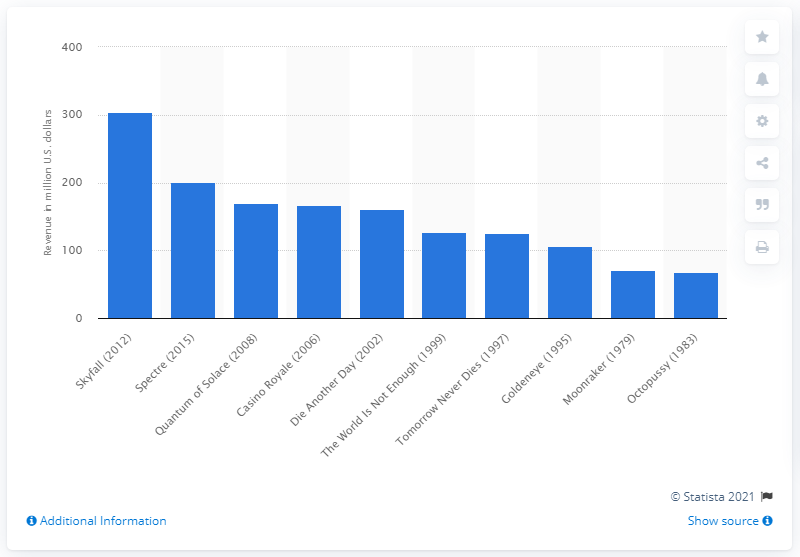List a handful of essential elements in this visual. The total gross revenue of "Skyfall" at the North American box office was $304.36 million. 